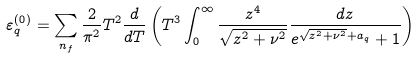<formula> <loc_0><loc_0><loc_500><loc_500>\varepsilon ^ { ( 0 ) } _ { q } = \sum _ { n _ { f } } \frac { 2 } { \pi ^ { 2 } } T ^ { 2 } \frac { d } { d T } \left ( T ^ { 3 } \int _ { 0 } ^ { \infty } \frac { z ^ { 4 } } { \sqrt { z ^ { 2 } + \nu ^ { 2 } } } \frac { d z } { e ^ { \sqrt { z ^ { 2 } + \nu ^ { 2 } } + a _ { q } } + 1 } \right )</formula> 